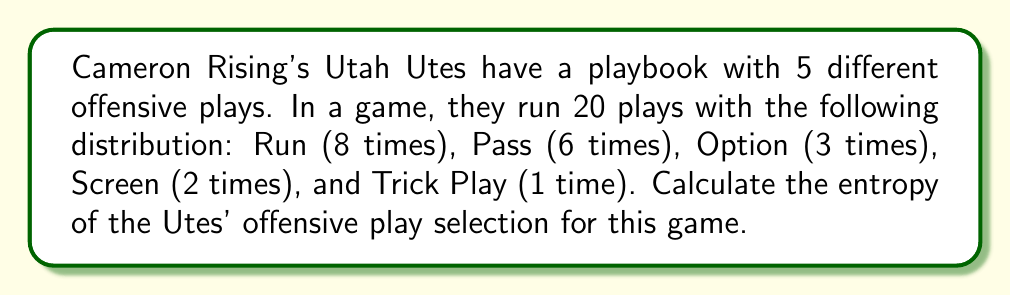Show me your answer to this math problem. To calculate the entropy of the Utes' offensive plays, we'll use the formula for Shannon entropy:

$$S = -\sum_{i=1}^{n} p_i \log_2(p_i)$$

Where $p_i$ is the probability of each play type.

Step 1: Calculate the probabilities for each play type:
- Run: $p_1 = 8/20 = 0.4$
- Pass: $p_2 = 6/20 = 0.3$
- Option: $p_3 = 3/20 = 0.15$
- Screen: $p_4 = 2/20 = 0.1$
- Trick Play: $p_5 = 1/20 = 0.05$

Step 2: Calculate each term in the sum:
- Run: $-0.4 \log_2(0.4) = 0.528771$
- Pass: $-0.3 \log_2(0.3) = 0.521148$
- Option: $-0.15 \log_2(0.15) = 0.410239$
- Screen: $-0.1 \log_2(0.1) = 0.332193$
- Trick Play: $-0.05 \log_2(0.05) = 0.216096$

Step 3: Sum all terms:
$$S = 0.528771 + 0.521148 + 0.410239 + 0.332193 + 0.216096 = 2.008447$$

The entropy of the Utes' offensive play selection is approximately 2.008447 bits.
Answer: 2.008447 bits 